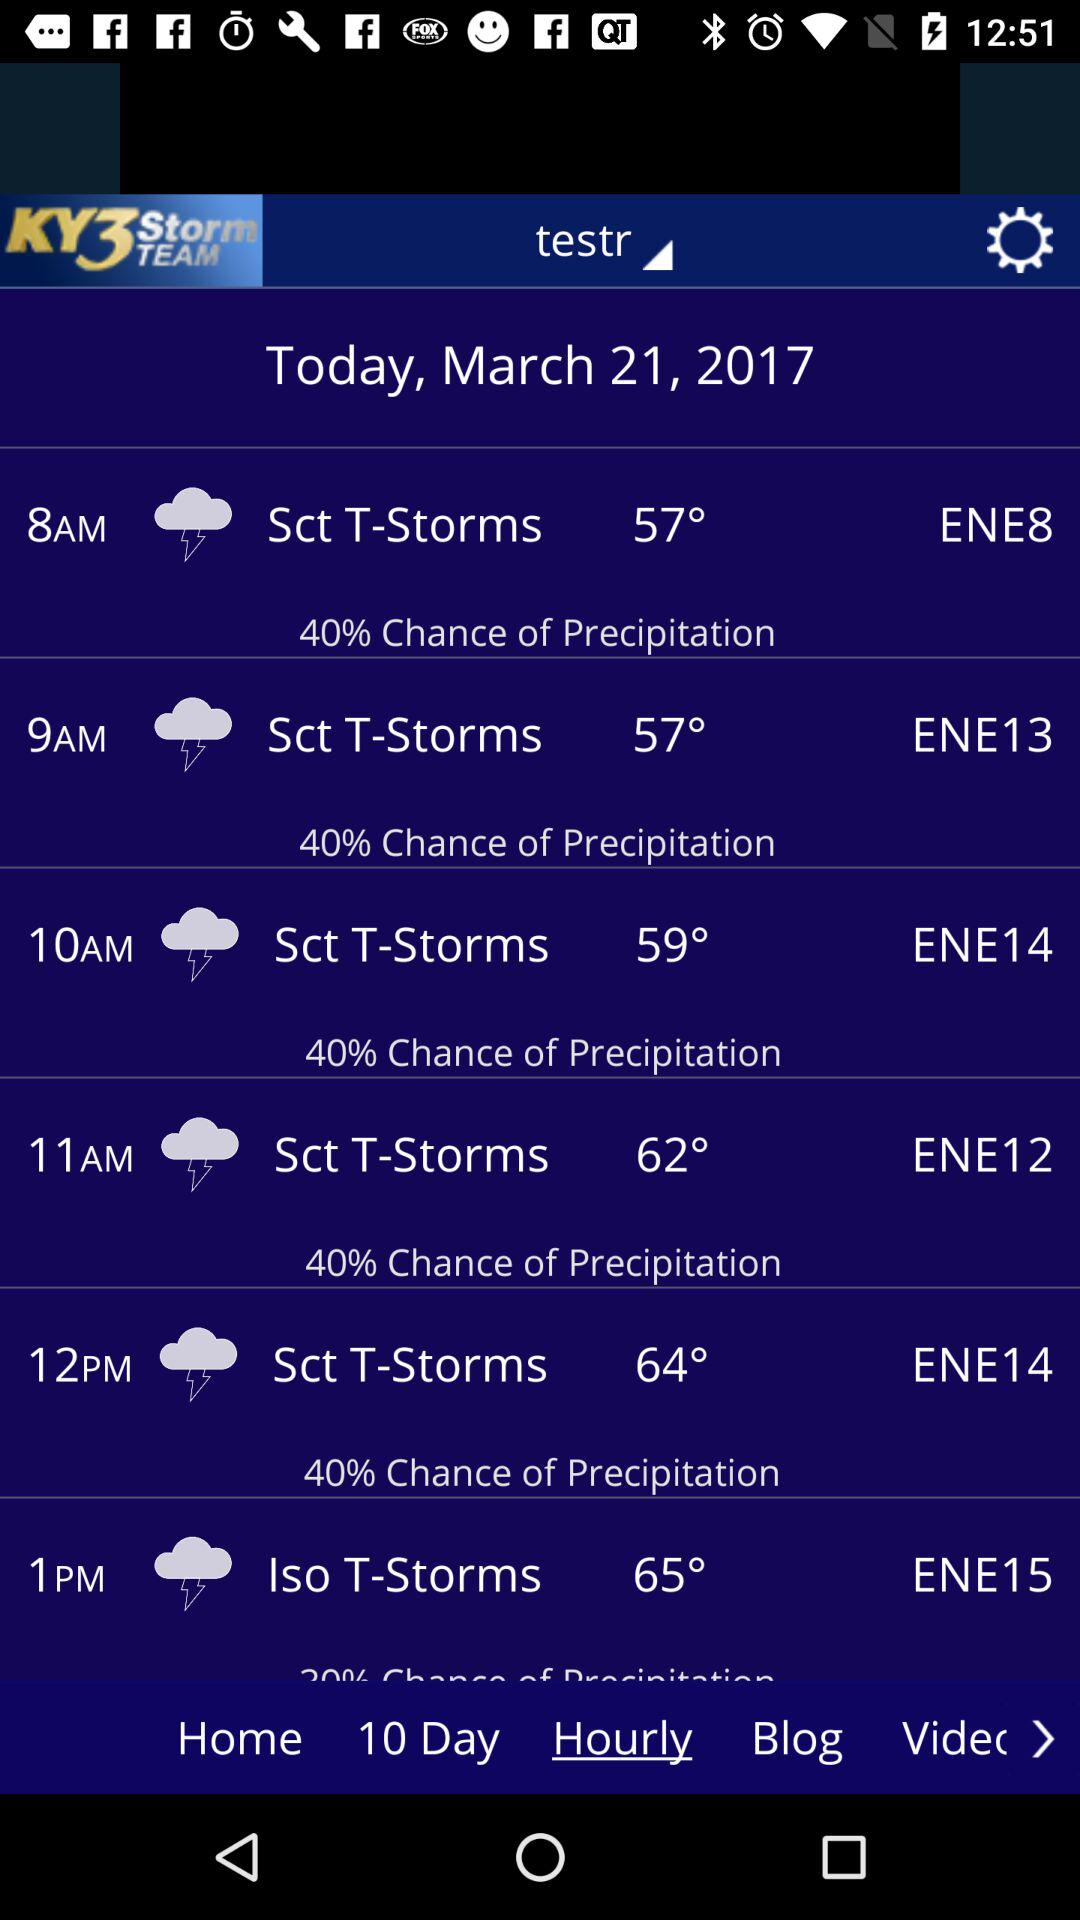What is the difference in temperature between the highest and lowest temperatures in the hourly forecast?
Answer the question using a single word or phrase. 8° 